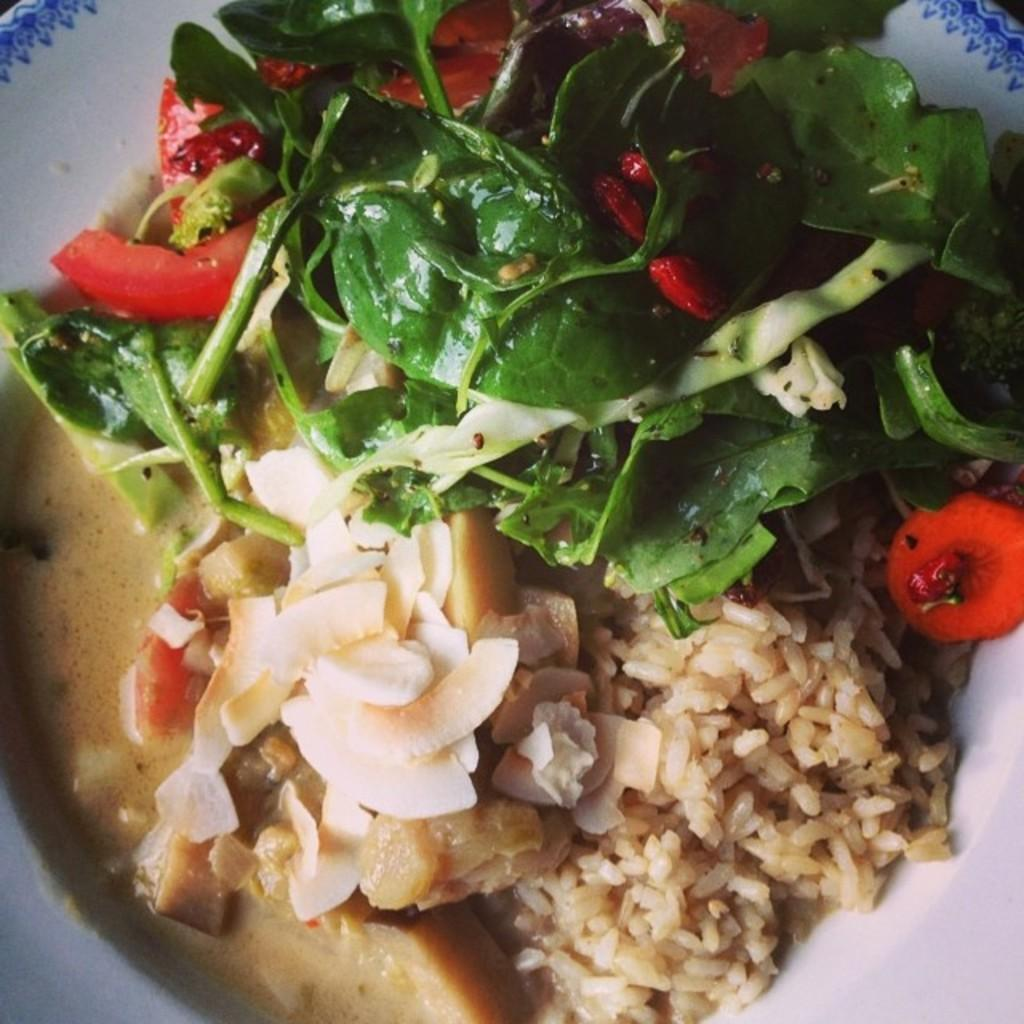What object is present in the image that might be used for serving food? There is a plate in the image. What is on the plate in the image? The plate contains food items, including rice and green leafy vegetables. What type of skate is being used to prepare the food in the image? There is no skate present in the image, and no food preparation is depicted. 